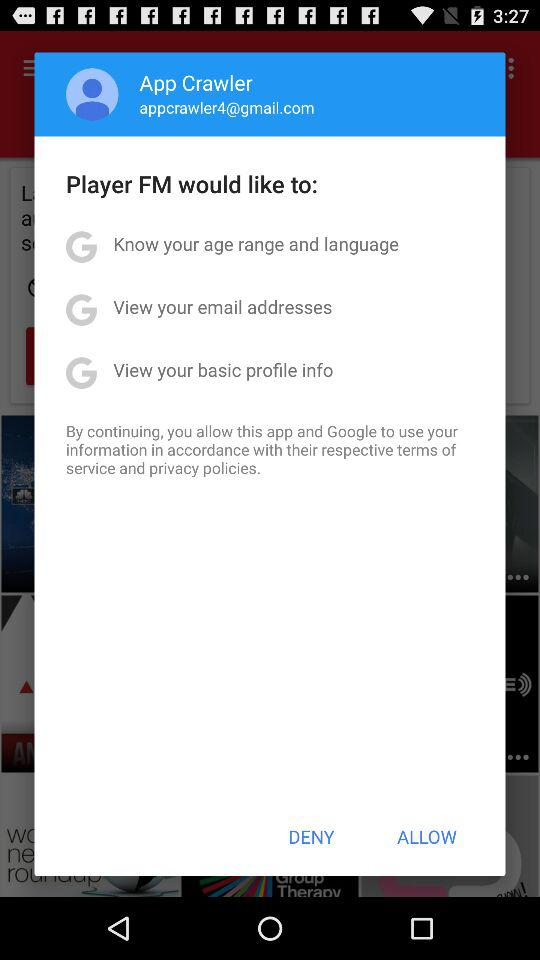What is the name of the person? The name of the person is App Crawler. 